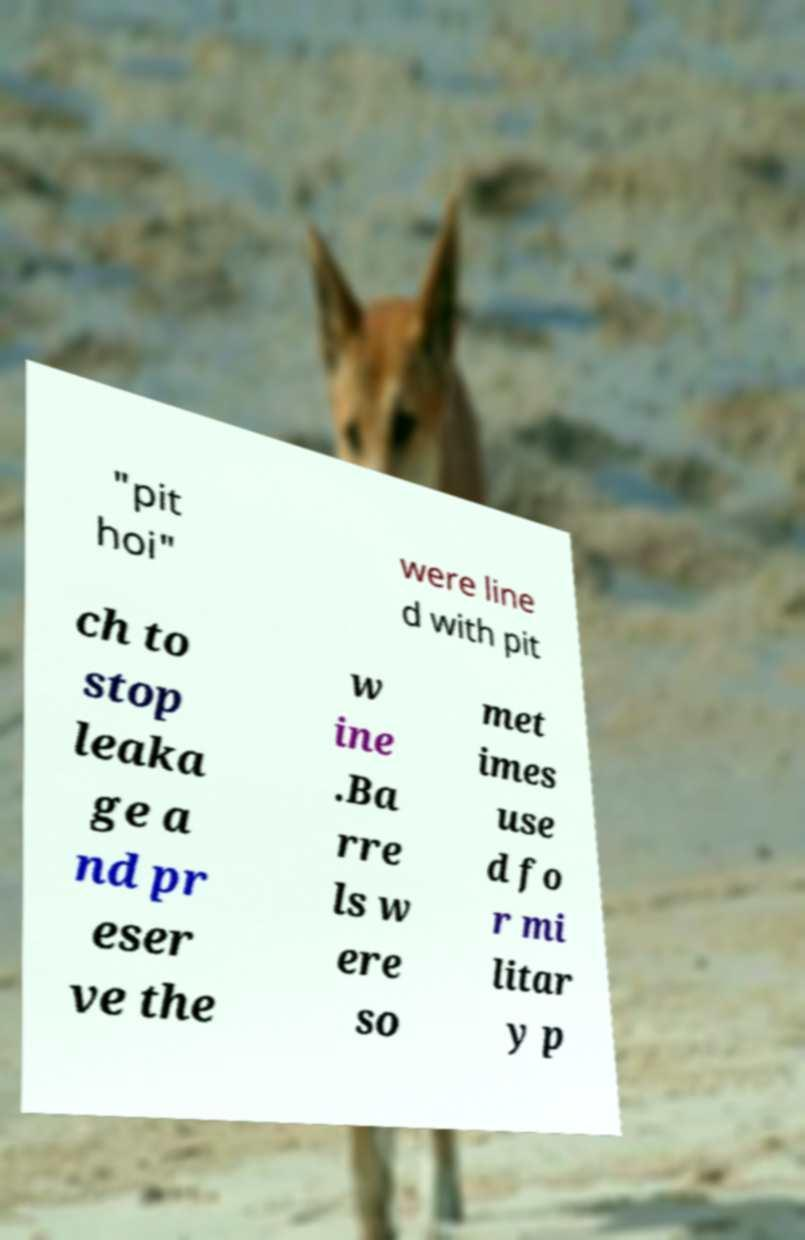Could you assist in decoding the text presented in this image and type it out clearly? "pit hoi" were line d with pit ch to stop leaka ge a nd pr eser ve the w ine .Ba rre ls w ere so met imes use d fo r mi litar y p 